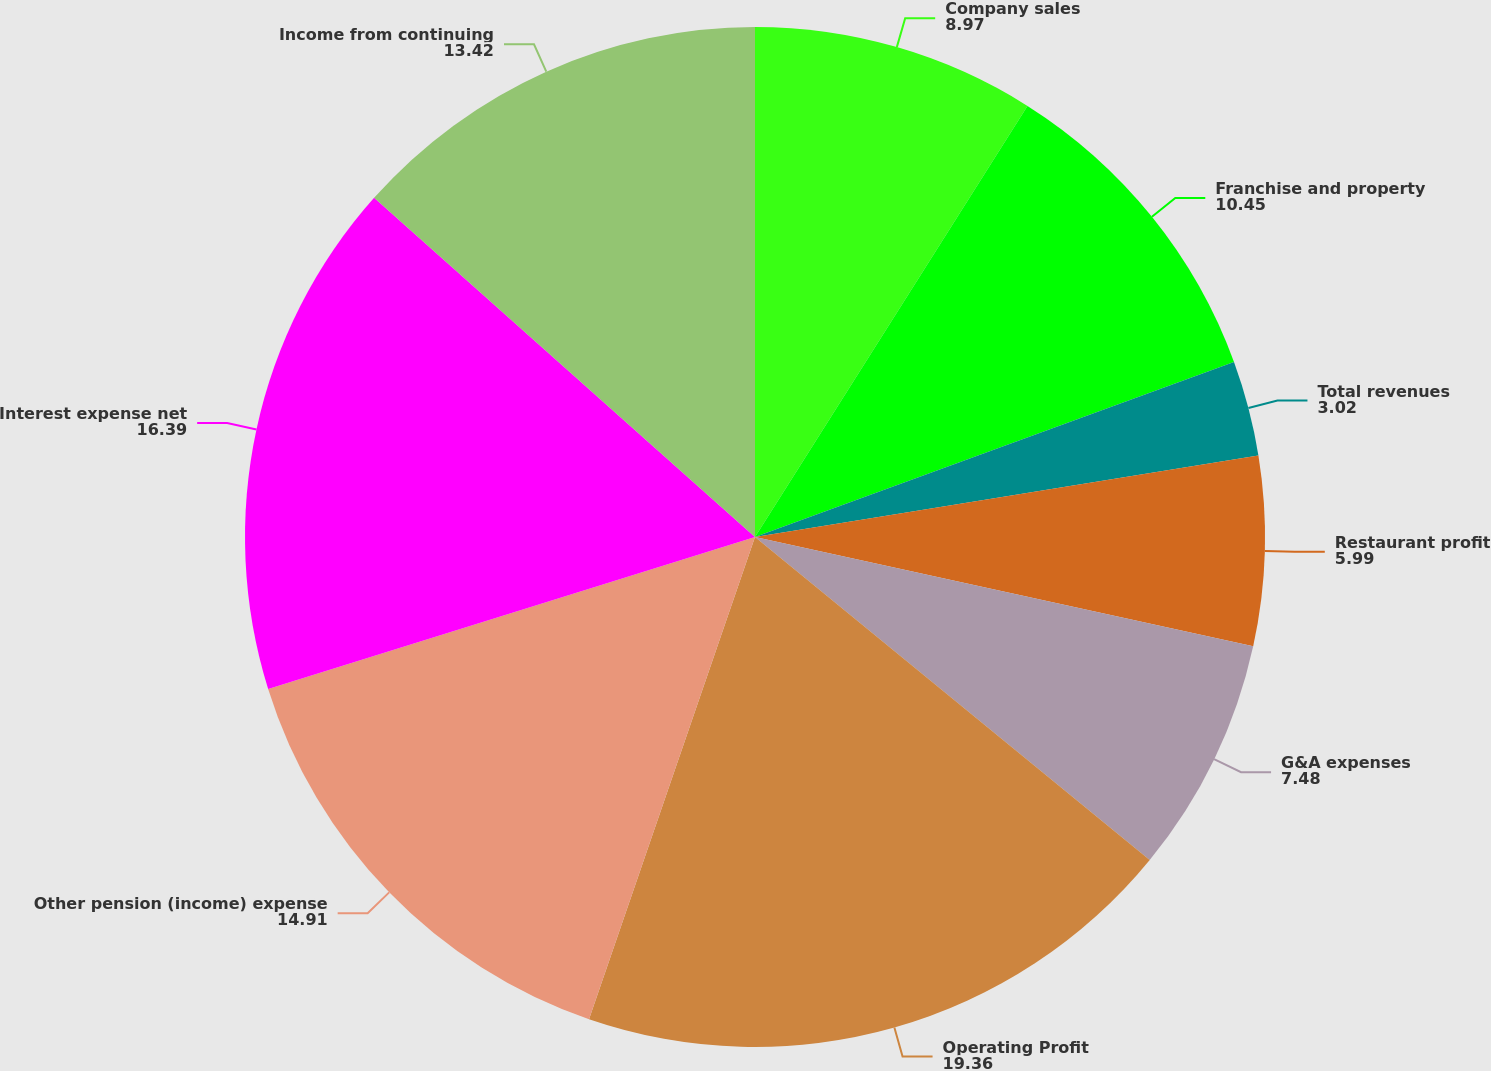Convert chart to OTSL. <chart><loc_0><loc_0><loc_500><loc_500><pie_chart><fcel>Company sales<fcel>Franchise and property<fcel>Total revenues<fcel>Restaurant profit<fcel>G&A expenses<fcel>Operating Profit<fcel>Other pension (income) expense<fcel>Interest expense net<fcel>Income from continuing<nl><fcel>8.97%<fcel>10.45%<fcel>3.02%<fcel>5.99%<fcel>7.48%<fcel>19.36%<fcel>14.91%<fcel>16.39%<fcel>13.42%<nl></chart> 